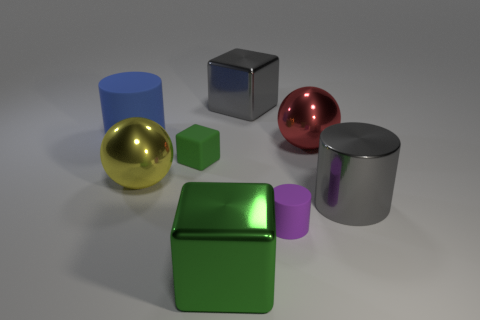Is there any other thing that is the same shape as the purple rubber thing?
Keep it short and to the point. Yes. Is the color of the shiny block that is behind the small cylinder the same as the large cylinder that is right of the tiny purple rubber cylinder?
Make the answer very short. Yes. What number of shiny objects are either gray cylinders or purple cylinders?
Your answer should be very brief. 1. There is a large green object that is to the left of the rubber cylinder in front of the blue thing; what shape is it?
Your answer should be compact. Cube. Does the large ball that is left of the green rubber object have the same material as the tiny cube that is on the right side of the big blue rubber cylinder?
Make the answer very short. No. There is a big cube that is behind the red shiny sphere; what number of yellow shiny balls are on the left side of it?
Your answer should be very brief. 1. Do the metal object behind the big red sphere and the big gray shiny thing in front of the big matte object have the same shape?
Your answer should be very brief. No. What size is the cylinder that is both behind the purple cylinder and in front of the large blue rubber cylinder?
Provide a short and direct response. Large. The other big rubber object that is the same shape as the purple matte object is what color?
Your answer should be very brief. Blue. What is the color of the shiny ball that is on the left side of the rubber cylinder in front of the large blue cylinder?
Give a very brief answer. Yellow. 